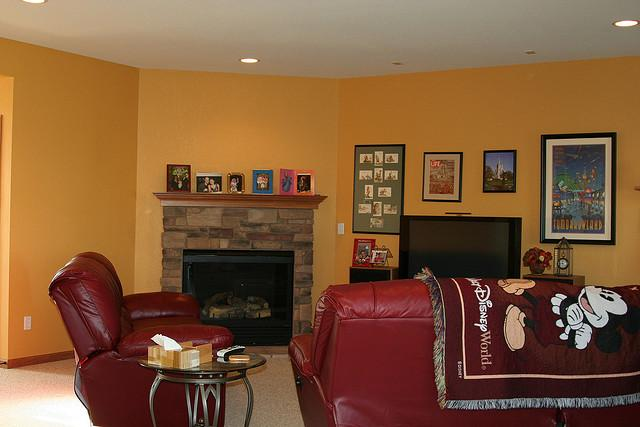What natural element might be found here? fire 